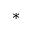<formula> <loc_0><loc_0><loc_500><loc_500>^ { * }</formula> 